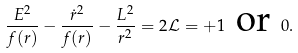<formula> <loc_0><loc_0><loc_500><loc_500>\frac { E ^ { 2 } } { f ( r ) } - \frac { \dot { r } ^ { 2 } } { f ( r ) } - \frac { L ^ { 2 } } { r ^ { 2 } } = 2 \mathcal { L } = + 1 \ \text {or} \ 0 .</formula> 